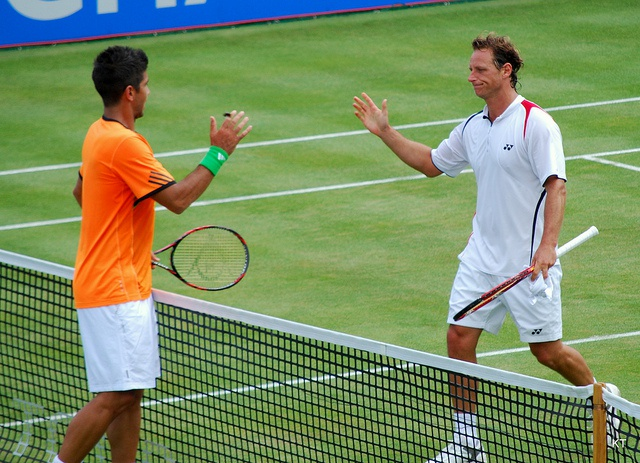Describe the objects in this image and their specific colors. I can see people in blue, red, lightblue, maroon, and black tones, people in blue, lavender, lightblue, darkgray, and brown tones, tennis racket in blue, olive, darkgray, and black tones, and tennis racket in blue, white, black, darkgray, and maroon tones in this image. 